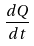Convert formula to latex. <formula><loc_0><loc_0><loc_500><loc_500>\frac { d Q } { d t }</formula> 